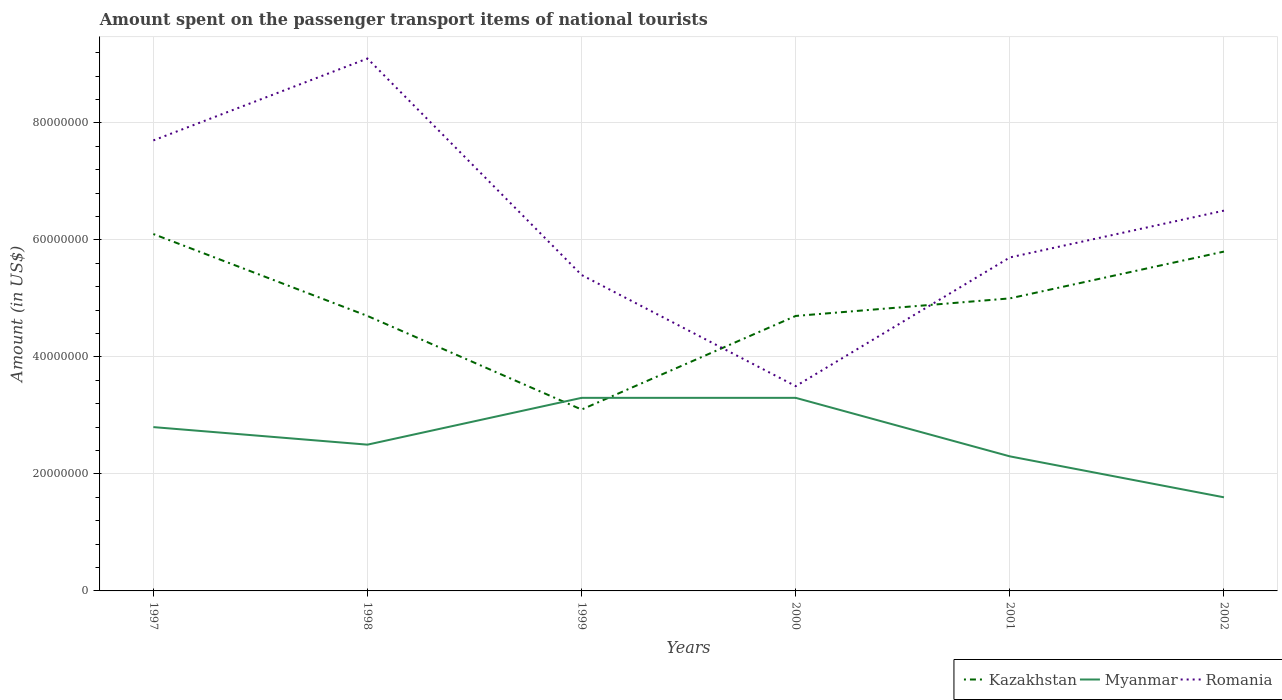How many different coloured lines are there?
Provide a succinct answer. 3. Is the number of lines equal to the number of legend labels?
Your answer should be compact. Yes. Across all years, what is the maximum amount spent on the passenger transport items of national tourists in Kazakhstan?
Offer a very short reply. 3.10e+07. In which year was the amount spent on the passenger transport items of national tourists in Myanmar maximum?
Offer a very short reply. 2002. What is the total amount spent on the passenger transport items of national tourists in Kazakhstan in the graph?
Make the answer very short. -1.90e+07. What is the difference between the highest and the second highest amount spent on the passenger transport items of national tourists in Romania?
Your answer should be very brief. 5.60e+07. What is the difference between the highest and the lowest amount spent on the passenger transport items of national tourists in Myanmar?
Offer a terse response. 3. How many lines are there?
Provide a short and direct response. 3. How many years are there in the graph?
Your response must be concise. 6. What is the difference between two consecutive major ticks on the Y-axis?
Offer a very short reply. 2.00e+07. Are the values on the major ticks of Y-axis written in scientific E-notation?
Your response must be concise. No. Does the graph contain grids?
Keep it short and to the point. Yes. How are the legend labels stacked?
Your answer should be compact. Horizontal. What is the title of the graph?
Your answer should be compact. Amount spent on the passenger transport items of national tourists. What is the Amount (in US$) of Kazakhstan in 1997?
Give a very brief answer. 6.10e+07. What is the Amount (in US$) of Myanmar in 1997?
Ensure brevity in your answer.  2.80e+07. What is the Amount (in US$) in Romania in 1997?
Offer a very short reply. 7.70e+07. What is the Amount (in US$) of Kazakhstan in 1998?
Offer a very short reply. 4.70e+07. What is the Amount (in US$) of Myanmar in 1998?
Your answer should be very brief. 2.50e+07. What is the Amount (in US$) of Romania in 1998?
Your answer should be very brief. 9.10e+07. What is the Amount (in US$) of Kazakhstan in 1999?
Your response must be concise. 3.10e+07. What is the Amount (in US$) of Myanmar in 1999?
Your response must be concise. 3.30e+07. What is the Amount (in US$) of Romania in 1999?
Give a very brief answer. 5.40e+07. What is the Amount (in US$) in Kazakhstan in 2000?
Make the answer very short. 4.70e+07. What is the Amount (in US$) in Myanmar in 2000?
Keep it short and to the point. 3.30e+07. What is the Amount (in US$) of Romania in 2000?
Give a very brief answer. 3.50e+07. What is the Amount (in US$) of Kazakhstan in 2001?
Provide a succinct answer. 5.00e+07. What is the Amount (in US$) of Myanmar in 2001?
Give a very brief answer. 2.30e+07. What is the Amount (in US$) of Romania in 2001?
Your answer should be compact. 5.70e+07. What is the Amount (in US$) of Kazakhstan in 2002?
Keep it short and to the point. 5.80e+07. What is the Amount (in US$) in Myanmar in 2002?
Offer a very short reply. 1.60e+07. What is the Amount (in US$) of Romania in 2002?
Provide a short and direct response. 6.50e+07. Across all years, what is the maximum Amount (in US$) of Kazakhstan?
Provide a short and direct response. 6.10e+07. Across all years, what is the maximum Amount (in US$) of Myanmar?
Keep it short and to the point. 3.30e+07. Across all years, what is the maximum Amount (in US$) of Romania?
Your answer should be compact. 9.10e+07. Across all years, what is the minimum Amount (in US$) in Kazakhstan?
Provide a short and direct response. 3.10e+07. Across all years, what is the minimum Amount (in US$) in Myanmar?
Keep it short and to the point. 1.60e+07. Across all years, what is the minimum Amount (in US$) of Romania?
Give a very brief answer. 3.50e+07. What is the total Amount (in US$) of Kazakhstan in the graph?
Keep it short and to the point. 2.94e+08. What is the total Amount (in US$) of Myanmar in the graph?
Provide a succinct answer. 1.58e+08. What is the total Amount (in US$) in Romania in the graph?
Provide a short and direct response. 3.79e+08. What is the difference between the Amount (in US$) in Kazakhstan in 1997 and that in 1998?
Make the answer very short. 1.40e+07. What is the difference between the Amount (in US$) of Myanmar in 1997 and that in 1998?
Your response must be concise. 3.00e+06. What is the difference between the Amount (in US$) of Romania in 1997 and that in 1998?
Make the answer very short. -1.40e+07. What is the difference between the Amount (in US$) in Kazakhstan in 1997 and that in 1999?
Provide a succinct answer. 3.00e+07. What is the difference between the Amount (in US$) of Myanmar in 1997 and that in 1999?
Your answer should be very brief. -5.00e+06. What is the difference between the Amount (in US$) in Romania in 1997 and that in 1999?
Your answer should be very brief. 2.30e+07. What is the difference between the Amount (in US$) of Kazakhstan in 1997 and that in 2000?
Your answer should be very brief. 1.40e+07. What is the difference between the Amount (in US$) in Myanmar in 1997 and that in 2000?
Offer a terse response. -5.00e+06. What is the difference between the Amount (in US$) of Romania in 1997 and that in 2000?
Provide a succinct answer. 4.20e+07. What is the difference between the Amount (in US$) of Kazakhstan in 1997 and that in 2001?
Give a very brief answer. 1.10e+07. What is the difference between the Amount (in US$) of Romania in 1997 and that in 2002?
Offer a terse response. 1.20e+07. What is the difference between the Amount (in US$) of Kazakhstan in 1998 and that in 1999?
Your response must be concise. 1.60e+07. What is the difference between the Amount (in US$) of Myanmar in 1998 and that in 1999?
Offer a very short reply. -8.00e+06. What is the difference between the Amount (in US$) in Romania in 1998 and that in 1999?
Provide a succinct answer. 3.70e+07. What is the difference between the Amount (in US$) in Myanmar in 1998 and that in 2000?
Your answer should be very brief. -8.00e+06. What is the difference between the Amount (in US$) of Romania in 1998 and that in 2000?
Make the answer very short. 5.60e+07. What is the difference between the Amount (in US$) of Myanmar in 1998 and that in 2001?
Make the answer very short. 2.00e+06. What is the difference between the Amount (in US$) in Romania in 1998 and that in 2001?
Ensure brevity in your answer.  3.40e+07. What is the difference between the Amount (in US$) in Kazakhstan in 1998 and that in 2002?
Keep it short and to the point. -1.10e+07. What is the difference between the Amount (in US$) of Myanmar in 1998 and that in 2002?
Provide a succinct answer. 9.00e+06. What is the difference between the Amount (in US$) in Romania in 1998 and that in 2002?
Your answer should be compact. 2.60e+07. What is the difference between the Amount (in US$) of Kazakhstan in 1999 and that in 2000?
Your response must be concise. -1.60e+07. What is the difference between the Amount (in US$) in Myanmar in 1999 and that in 2000?
Make the answer very short. 0. What is the difference between the Amount (in US$) in Romania in 1999 and that in 2000?
Your response must be concise. 1.90e+07. What is the difference between the Amount (in US$) of Kazakhstan in 1999 and that in 2001?
Offer a terse response. -1.90e+07. What is the difference between the Amount (in US$) of Myanmar in 1999 and that in 2001?
Offer a very short reply. 1.00e+07. What is the difference between the Amount (in US$) of Kazakhstan in 1999 and that in 2002?
Offer a terse response. -2.70e+07. What is the difference between the Amount (in US$) in Myanmar in 1999 and that in 2002?
Provide a succinct answer. 1.70e+07. What is the difference between the Amount (in US$) in Romania in 1999 and that in 2002?
Ensure brevity in your answer.  -1.10e+07. What is the difference between the Amount (in US$) in Myanmar in 2000 and that in 2001?
Offer a terse response. 1.00e+07. What is the difference between the Amount (in US$) of Romania in 2000 and that in 2001?
Ensure brevity in your answer.  -2.20e+07. What is the difference between the Amount (in US$) in Kazakhstan in 2000 and that in 2002?
Your answer should be very brief. -1.10e+07. What is the difference between the Amount (in US$) in Myanmar in 2000 and that in 2002?
Your answer should be very brief. 1.70e+07. What is the difference between the Amount (in US$) in Romania in 2000 and that in 2002?
Keep it short and to the point. -3.00e+07. What is the difference between the Amount (in US$) in Kazakhstan in 2001 and that in 2002?
Your answer should be compact. -8.00e+06. What is the difference between the Amount (in US$) in Romania in 2001 and that in 2002?
Offer a terse response. -8.00e+06. What is the difference between the Amount (in US$) of Kazakhstan in 1997 and the Amount (in US$) of Myanmar in 1998?
Ensure brevity in your answer.  3.60e+07. What is the difference between the Amount (in US$) in Kazakhstan in 1997 and the Amount (in US$) in Romania in 1998?
Your answer should be very brief. -3.00e+07. What is the difference between the Amount (in US$) in Myanmar in 1997 and the Amount (in US$) in Romania in 1998?
Ensure brevity in your answer.  -6.30e+07. What is the difference between the Amount (in US$) in Kazakhstan in 1997 and the Amount (in US$) in Myanmar in 1999?
Offer a very short reply. 2.80e+07. What is the difference between the Amount (in US$) of Myanmar in 1997 and the Amount (in US$) of Romania in 1999?
Offer a very short reply. -2.60e+07. What is the difference between the Amount (in US$) in Kazakhstan in 1997 and the Amount (in US$) in Myanmar in 2000?
Provide a short and direct response. 2.80e+07. What is the difference between the Amount (in US$) of Kazakhstan in 1997 and the Amount (in US$) of Romania in 2000?
Offer a terse response. 2.60e+07. What is the difference between the Amount (in US$) of Myanmar in 1997 and the Amount (in US$) of Romania in 2000?
Your response must be concise. -7.00e+06. What is the difference between the Amount (in US$) of Kazakhstan in 1997 and the Amount (in US$) of Myanmar in 2001?
Your answer should be very brief. 3.80e+07. What is the difference between the Amount (in US$) in Kazakhstan in 1997 and the Amount (in US$) in Romania in 2001?
Provide a succinct answer. 4.00e+06. What is the difference between the Amount (in US$) of Myanmar in 1997 and the Amount (in US$) of Romania in 2001?
Offer a very short reply. -2.90e+07. What is the difference between the Amount (in US$) in Kazakhstan in 1997 and the Amount (in US$) in Myanmar in 2002?
Your answer should be very brief. 4.50e+07. What is the difference between the Amount (in US$) of Myanmar in 1997 and the Amount (in US$) of Romania in 2002?
Give a very brief answer. -3.70e+07. What is the difference between the Amount (in US$) of Kazakhstan in 1998 and the Amount (in US$) of Myanmar in 1999?
Your answer should be compact. 1.40e+07. What is the difference between the Amount (in US$) in Kazakhstan in 1998 and the Amount (in US$) in Romania in 1999?
Ensure brevity in your answer.  -7.00e+06. What is the difference between the Amount (in US$) of Myanmar in 1998 and the Amount (in US$) of Romania in 1999?
Provide a succinct answer. -2.90e+07. What is the difference between the Amount (in US$) of Kazakhstan in 1998 and the Amount (in US$) of Myanmar in 2000?
Give a very brief answer. 1.40e+07. What is the difference between the Amount (in US$) of Kazakhstan in 1998 and the Amount (in US$) of Romania in 2000?
Your response must be concise. 1.20e+07. What is the difference between the Amount (in US$) of Myanmar in 1998 and the Amount (in US$) of Romania in 2000?
Your answer should be very brief. -1.00e+07. What is the difference between the Amount (in US$) of Kazakhstan in 1998 and the Amount (in US$) of Myanmar in 2001?
Provide a succinct answer. 2.40e+07. What is the difference between the Amount (in US$) of Kazakhstan in 1998 and the Amount (in US$) of Romania in 2001?
Provide a short and direct response. -1.00e+07. What is the difference between the Amount (in US$) of Myanmar in 1998 and the Amount (in US$) of Romania in 2001?
Provide a short and direct response. -3.20e+07. What is the difference between the Amount (in US$) in Kazakhstan in 1998 and the Amount (in US$) in Myanmar in 2002?
Your answer should be very brief. 3.10e+07. What is the difference between the Amount (in US$) of Kazakhstan in 1998 and the Amount (in US$) of Romania in 2002?
Provide a short and direct response. -1.80e+07. What is the difference between the Amount (in US$) of Myanmar in 1998 and the Amount (in US$) of Romania in 2002?
Make the answer very short. -4.00e+07. What is the difference between the Amount (in US$) of Kazakhstan in 1999 and the Amount (in US$) of Myanmar in 2000?
Provide a succinct answer. -2.00e+06. What is the difference between the Amount (in US$) of Myanmar in 1999 and the Amount (in US$) of Romania in 2000?
Your answer should be very brief. -2.00e+06. What is the difference between the Amount (in US$) in Kazakhstan in 1999 and the Amount (in US$) in Romania in 2001?
Give a very brief answer. -2.60e+07. What is the difference between the Amount (in US$) in Myanmar in 1999 and the Amount (in US$) in Romania in 2001?
Your response must be concise. -2.40e+07. What is the difference between the Amount (in US$) of Kazakhstan in 1999 and the Amount (in US$) of Myanmar in 2002?
Offer a terse response. 1.50e+07. What is the difference between the Amount (in US$) of Kazakhstan in 1999 and the Amount (in US$) of Romania in 2002?
Keep it short and to the point. -3.40e+07. What is the difference between the Amount (in US$) in Myanmar in 1999 and the Amount (in US$) in Romania in 2002?
Keep it short and to the point. -3.20e+07. What is the difference between the Amount (in US$) in Kazakhstan in 2000 and the Amount (in US$) in Myanmar in 2001?
Keep it short and to the point. 2.40e+07. What is the difference between the Amount (in US$) in Kazakhstan in 2000 and the Amount (in US$) in Romania in 2001?
Your answer should be very brief. -1.00e+07. What is the difference between the Amount (in US$) of Myanmar in 2000 and the Amount (in US$) of Romania in 2001?
Make the answer very short. -2.40e+07. What is the difference between the Amount (in US$) of Kazakhstan in 2000 and the Amount (in US$) of Myanmar in 2002?
Your answer should be compact. 3.10e+07. What is the difference between the Amount (in US$) of Kazakhstan in 2000 and the Amount (in US$) of Romania in 2002?
Ensure brevity in your answer.  -1.80e+07. What is the difference between the Amount (in US$) of Myanmar in 2000 and the Amount (in US$) of Romania in 2002?
Offer a very short reply. -3.20e+07. What is the difference between the Amount (in US$) of Kazakhstan in 2001 and the Amount (in US$) of Myanmar in 2002?
Your answer should be compact. 3.40e+07. What is the difference between the Amount (in US$) of Kazakhstan in 2001 and the Amount (in US$) of Romania in 2002?
Ensure brevity in your answer.  -1.50e+07. What is the difference between the Amount (in US$) of Myanmar in 2001 and the Amount (in US$) of Romania in 2002?
Your answer should be very brief. -4.20e+07. What is the average Amount (in US$) in Kazakhstan per year?
Provide a succinct answer. 4.90e+07. What is the average Amount (in US$) of Myanmar per year?
Offer a very short reply. 2.63e+07. What is the average Amount (in US$) in Romania per year?
Ensure brevity in your answer.  6.32e+07. In the year 1997, what is the difference between the Amount (in US$) in Kazakhstan and Amount (in US$) in Myanmar?
Give a very brief answer. 3.30e+07. In the year 1997, what is the difference between the Amount (in US$) of Kazakhstan and Amount (in US$) of Romania?
Your response must be concise. -1.60e+07. In the year 1997, what is the difference between the Amount (in US$) of Myanmar and Amount (in US$) of Romania?
Provide a short and direct response. -4.90e+07. In the year 1998, what is the difference between the Amount (in US$) of Kazakhstan and Amount (in US$) of Myanmar?
Your answer should be very brief. 2.20e+07. In the year 1998, what is the difference between the Amount (in US$) in Kazakhstan and Amount (in US$) in Romania?
Your response must be concise. -4.40e+07. In the year 1998, what is the difference between the Amount (in US$) of Myanmar and Amount (in US$) of Romania?
Provide a short and direct response. -6.60e+07. In the year 1999, what is the difference between the Amount (in US$) of Kazakhstan and Amount (in US$) of Myanmar?
Provide a short and direct response. -2.00e+06. In the year 1999, what is the difference between the Amount (in US$) in Kazakhstan and Amount (in US$) in Romania?
Your answer should be very brief. -2.30e+07. In the year 1999, what is the difference between the Amount (in US$) of Myanmar and Amount (in US$) of Romania?
Provide a succinct answer. -2.10e+07. In the year 2000, what is the difference between the Amount (in US$) of Kazakhstan and Amount (in US$) of Myanmar?
Ensure brevity in your answer.  1.40e+07. In the year 2001, what is the difference between the Amount (in US$) of Kazakhstan and Amount (in US$) of Myanmar?
Your answer should be compact. 2.70e+07. In the year 2001, what is the difference between the Amount (in US$) in Kazakhstan and Amount (in US$) in Romania?
Keep it short and to the point. -7.00e+06. In the year 2001, what is the difference between the Amount (in US$) in Myanmar and Amount (in US$) in Romania?
Keep it short and to the point. -3.40e+07. In the year 2002, what is the difference between the Amount (in US$) in Kazakhstan and Amount (in US$) in Myanmar?
Ensure brevity in your answer.  4.20e+07. In the year 2002, what is the difference between the Amount (in US$) of Kazakhstan and Amount (in US$) of Romania?
Your answer should be very brief. -7.00e+06. In the year 2002, what is the difference between the Amount (in US$) in Myanmar and Amount (in US$) in Romania?
Offer a very short reply. -4.90e+07. What is the ratio of the Amount (in US$) in Kazakhstan in 1997 to that in 1998?
Your answer should be compact. 1.3. What is the ratio of the Amount (in US$) of Myanmar in 1997 to that in 1998?
Ensure brevity in your answer.  1.12. What is the ratio of the Amount (in US$) of Romania in 1997 to that in 1998?
Your response must be concise. 0.85. What is the ratio of the Amount (in US$) of Kazakhstan in 1997 to that in 1999?
Your answer should be compact. 1.97. What is the ratio of the Amount (in US$) of Myanmar in 1997 to that in 1999?
Your response must be concise. 0.85. What is the ratio of the Amount (in US$) in Romania in 1997 to that in 1999?
Provide a short and direct response. 1.43. What is the ratio of the Amount (in US$) in Kazakhstan in 1997 to that in 2000?
Ensure brevity in your answer.  1.3. What is the ratio of the Amount (in US$) in Myanmar in 1997 to that in 2000?
Keep it short and to the point. 0.85. What is the ratio of the Amount (in US$) of Romania in 1997 to that in 2000?
Ensure brevity in your answer.  2.2. What is the ratio of the Amount (in US$) of Kazakhstan in 1997 to that in 2001?
Keep it short and to the point. 1.22. What is the ratio of the Amount (in US$) in Myanmar in 1997 to that in 2001?
Ensure brevity in your answer.  1.22. What is the ratio of the Amount (in US$) in Romania in 1997 to that in 2001?
Your response must be concise. 1.35. What is the ratio of the Amount (in US$) of Kazakhstan in 1997 to that in 2002?
Keep it short and to the point. 1.05. What is the ratio of the Amount (in US$) of Myanmar in 1997 to that in 2002?
Keep it short and to the point. 1.75. What is the ratio of the Amount (in US$) in Romania in 1997 to that in 2002?
Ensure brevity in your answer.  1.18. What is the ratio of the Amount (in US$) in Kazakhstan in 1998 to that in 1999?
Your answer should be very brief. 1.52. What is the ratio of the Amount (in US$) in Myanmar in 1998 to that in 1999?
Ensure brevity in your answer.  0.76. What is the ratio of the Amount (in US$) of Romania in 1998 to that in 1999?
Your answer should be compact. 1.69. What is the ratio of the Amount (in US$) in Kazakhstan in 1998 to that in 2000?
Your answer should be compact. 1. What is the ratio of the Amount (in US$) in Myanmar in 1998 to that in 2000?
Your answer should be very brief. 0.76. What is the ratio of the Amount (in US$) of Myanmar in 1998 to that in 2001?
Ensure brevity in your answer.  1.09. What is the ratio of the Amount (in US$) of Romania in 1998 to that in 2001?
Provide a succinct answer. 1.6. What is the ratio of the Amount (in US$) in Kazakhstan in 1998 to that in 2002?
Your answer should be very brief. 0.81. What is the ratio of the Amount (in US$) in Myanmar in 1998 to that in 2002?
Provide a succinct answer. 1.56. What is the ratio of the Amount (in US$) in Kazakhstan in 1999 to that in 2000?
Give a very brief answer. 0.66. What is the ratio of the Amount (in US$) of Romania in 1999 to that in 2000?
Offer a terse response. 1.54. What is the ratio of the Amount (in US$) of Kazakhstan in 1999 to that in 2001?
Provide a succinct answer. 0.62. What is the ratio of the Amount (in US$) in Myanmar in 1999 to that in 2001?
Offer a very short reply. 1.43. What is the ratio of the Amount (in US$) in Kazakhstan in 1999 to that in 2002?
Offer a terse response. 0.53. What is the ratio of the Amount (in US$) in Myanmar in 1999 to that in 2002?
Provide a succinct answer. 2.06. What is the ratio of the Amount (in US$) of Romania in 1999 to that in 2002?
Ensure brevity in your answer.  0.83. What is the ratio of the Amount (in US$) of Kazakhstan in 2000 to that in 2001?
Provide a succinct answer. 0.94. What is the ratio of the Amount (in US$) of Myanmar in 2000 to that in 2001?
Give a very brief answer. 1.43. What is the ratio of the Amount (in US$) in Romania in 2000 to that in 2001?
Provide a succinct answer. 0.61. What is the ratio of the Amount (in US$) of Kazakhstan in 2000 to that in 2002?
Provide a succinct answer. 0.81. What is the ratio of the Amount (in US$) of Myanmar in 2000 to that in 2002?
Offer a very short reply. 2.06. What is the ratio of the Amount (in US$) in Romania in 2000 to that in 2002?
Your answer should be compact. 0.54. What is the ratio of the Amount (in US$) of Kazakhstan in 2001 to that in 2002?
Give a very brief answer. 0.86. What is the ratio of the Amount (in US$) in Myanmar in 2001 to that in 2002?
Your response must be concise. 1.44. What is the ratio of the Amount (in US$) of Romania in 2001 to that in 2002?
Your answer should be compact. 0.88. What is the difference between the highest and the second highest Amount (in US$) of Romania?
Keep it short and to the point. 1.40e+07. What is the difference between the highest and the lowest Amount (in US$) in Kazakhstan?
Your response must be concise. 3.00e+07. What is the difference between the highest and the lowest Amount (in US$) in Myanmar?
Keep it short and to the point. 1.70e+07. What is the difference between the highest and the lowest Amount (in US$) in Romania?
Provide a succinct answer. 5.60e+07. 